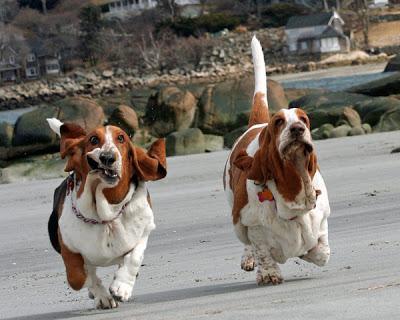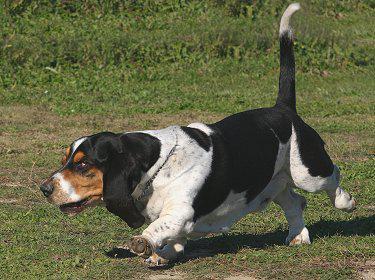The first image is the image on the left, the second image is the image on the right. Assess this claim about the two images: "There are dogs running on pavement.". Correct or not? Answer yes or no. Yes. 